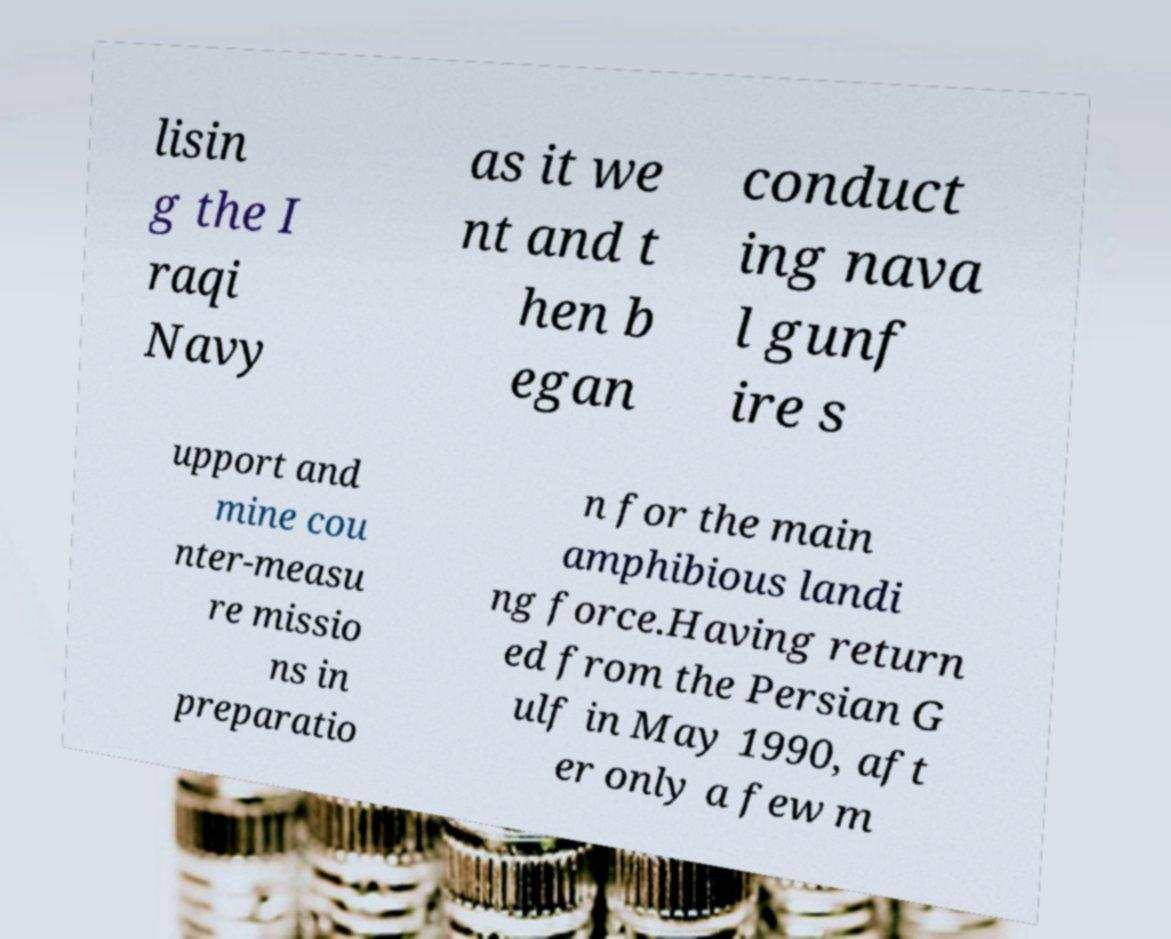Please identify and transcribe the text found in this image. lisin g the I raqi Navy as it we nt and t hen b egan conduct ing nava l gunf ire s upport and mine cou nter-measu re missio ns in preparatio n for the main amphibious landi ng force.Having return ed from the Persian G ulf in May 1990, aft er only a few m 